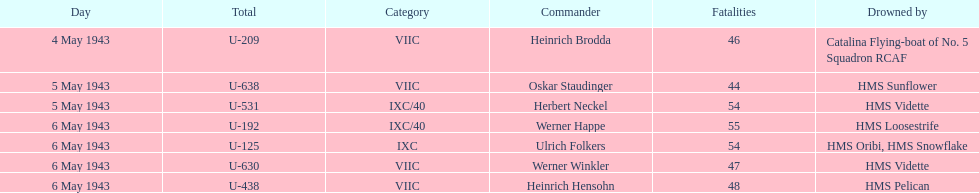Which sunken u-boat had the most casualties U-192. 